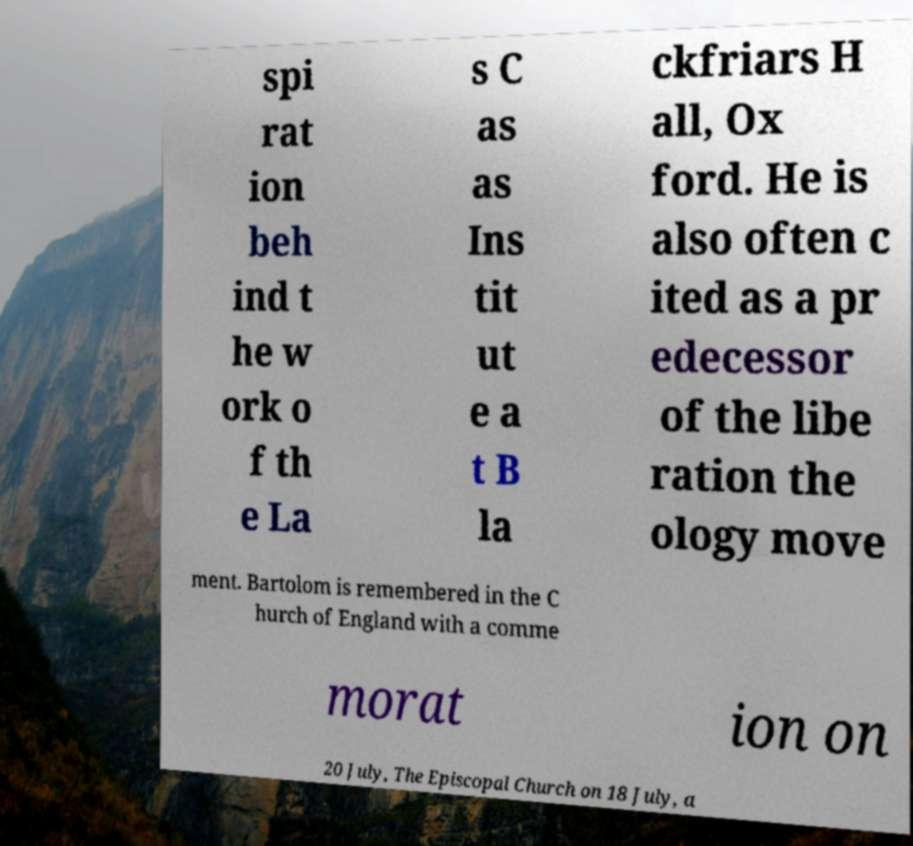Please read and relay the text visible in this image. What does it say? spi rat ion beh ind t he w ork o f th e La s C as as Ins tit ut e a t B la ckfriars H all, Ox ford. He is also often c ited as a pr edecessor of the libe ration the ology move ment. Bartolom is remembered in the C hurch of England with a comme morat ion on 20 July, The Episcopal Church on 18 July, a 